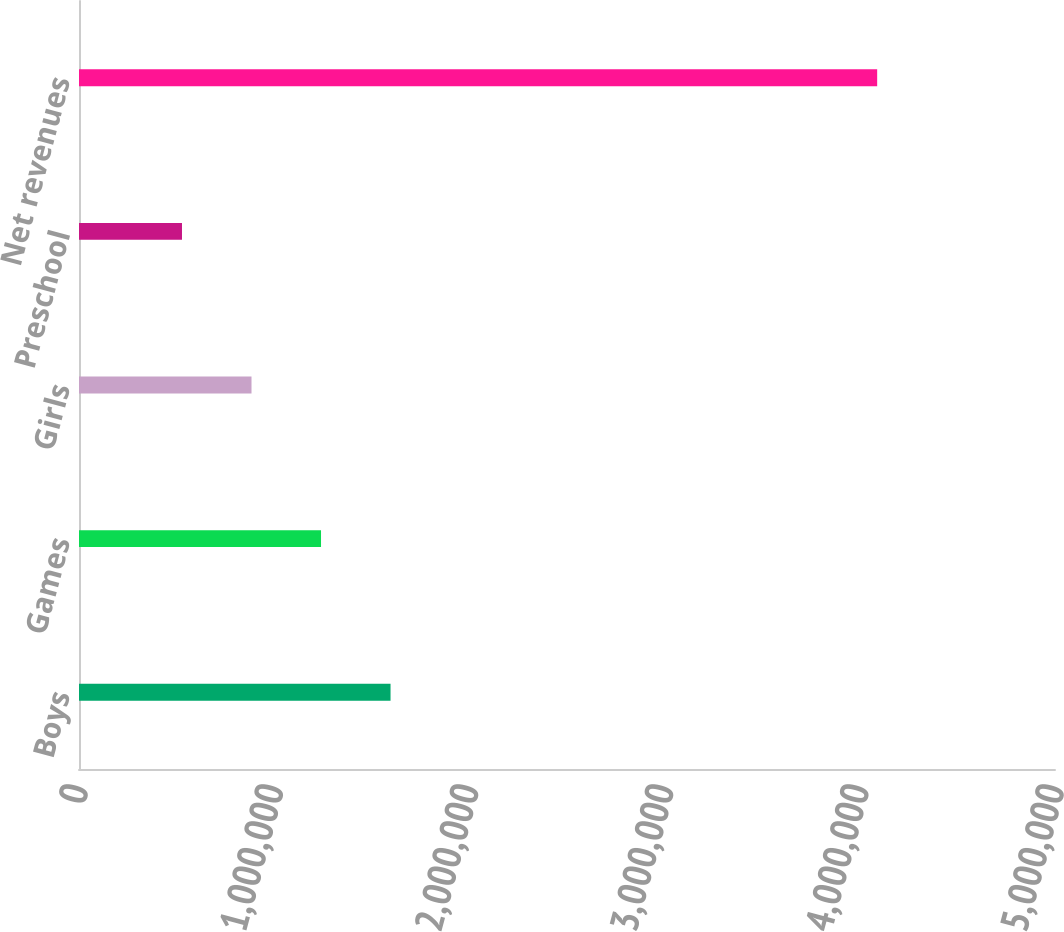Convert chart to OTSL. <chart><loc_0><loc_0><loc_500><loc_500><bar_chart><fcel>Boys<fcel>Games<fcel>Girls<fcel>Preschool<fcel>Net revenues<nl><fcel>1.59601e+06<fcel>1.23987e+06<fcel>883730<fcel>527591<fcel>4.08898e+06<nl></chart> 